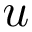Convert formula to latex. <formula><loc_0><loc_0><loc_500><loc_500>u</formula> 